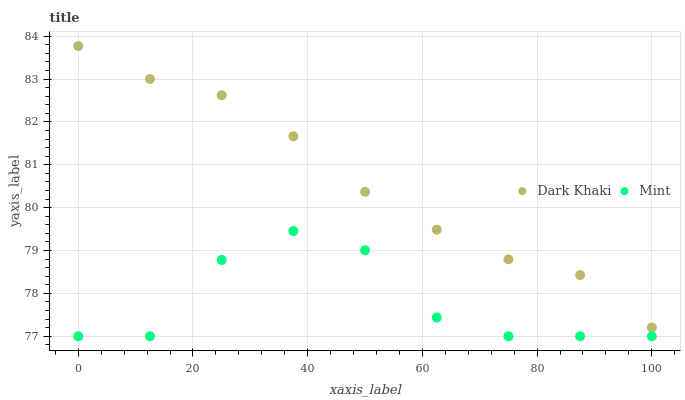Does Mint have the minimum area under the curve?
Answer yes or no. Yes. Does Dark Khaki have the maximum area under the curve?
Answer yes or no. Yes. Does Mint have the maximum area under the curve?
Answer yes or no. No. Is Dark Khaki the smoothest?
Answer yes or no. Yes. Is Mint the roughest?
Answer yes or no. Yes. Is Mint the smoothest?
Answer yes or no. No. Does Mint have the lowest value?
Answer yes or no. Yes. Does Dark Khaki have the highest value?
Answer yes or no. Yes. Does Mint have the highest value?
Answer yes or no. No. Is Mint less than Dark Khaki?
Answer yes or no. Yes. Is Dark Khaki greater than Mint?
Answer yes or no. Yes. Does Mint intersect Dark Khaki?
Answer yes or no. No. 